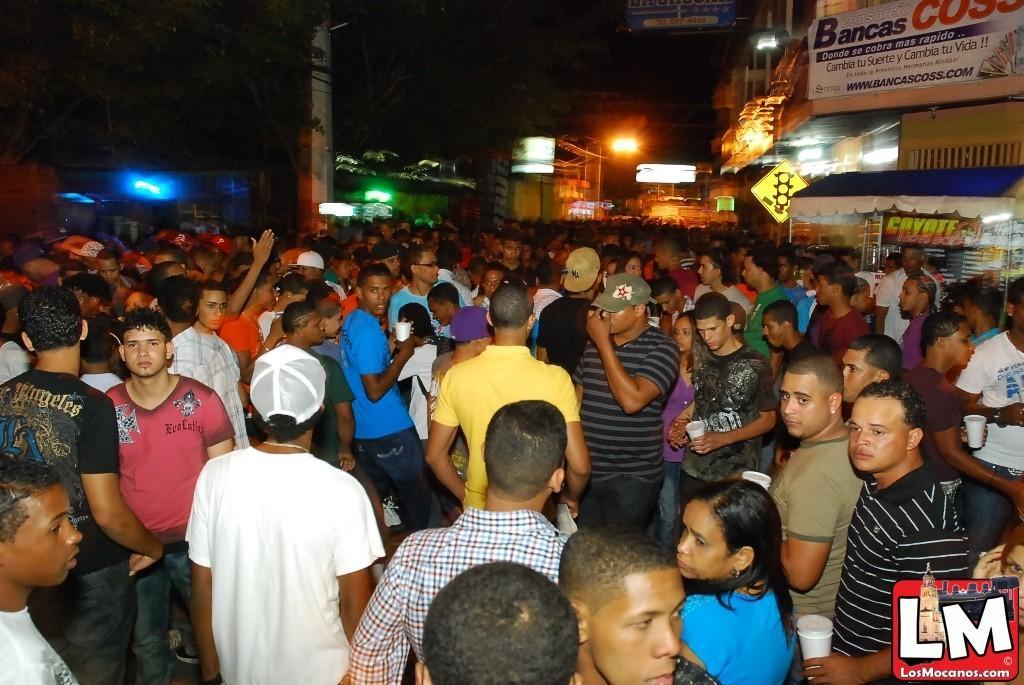How would you summarize this image in a sentence or two? This picture is clicked outside. In the center we can see the group of people standing on the ground, in which some of them are holding glasses. In the background we can see the sky, buildings, lights and banners on which the text is printed. On the bottom right corner there is a watermark on the image. 